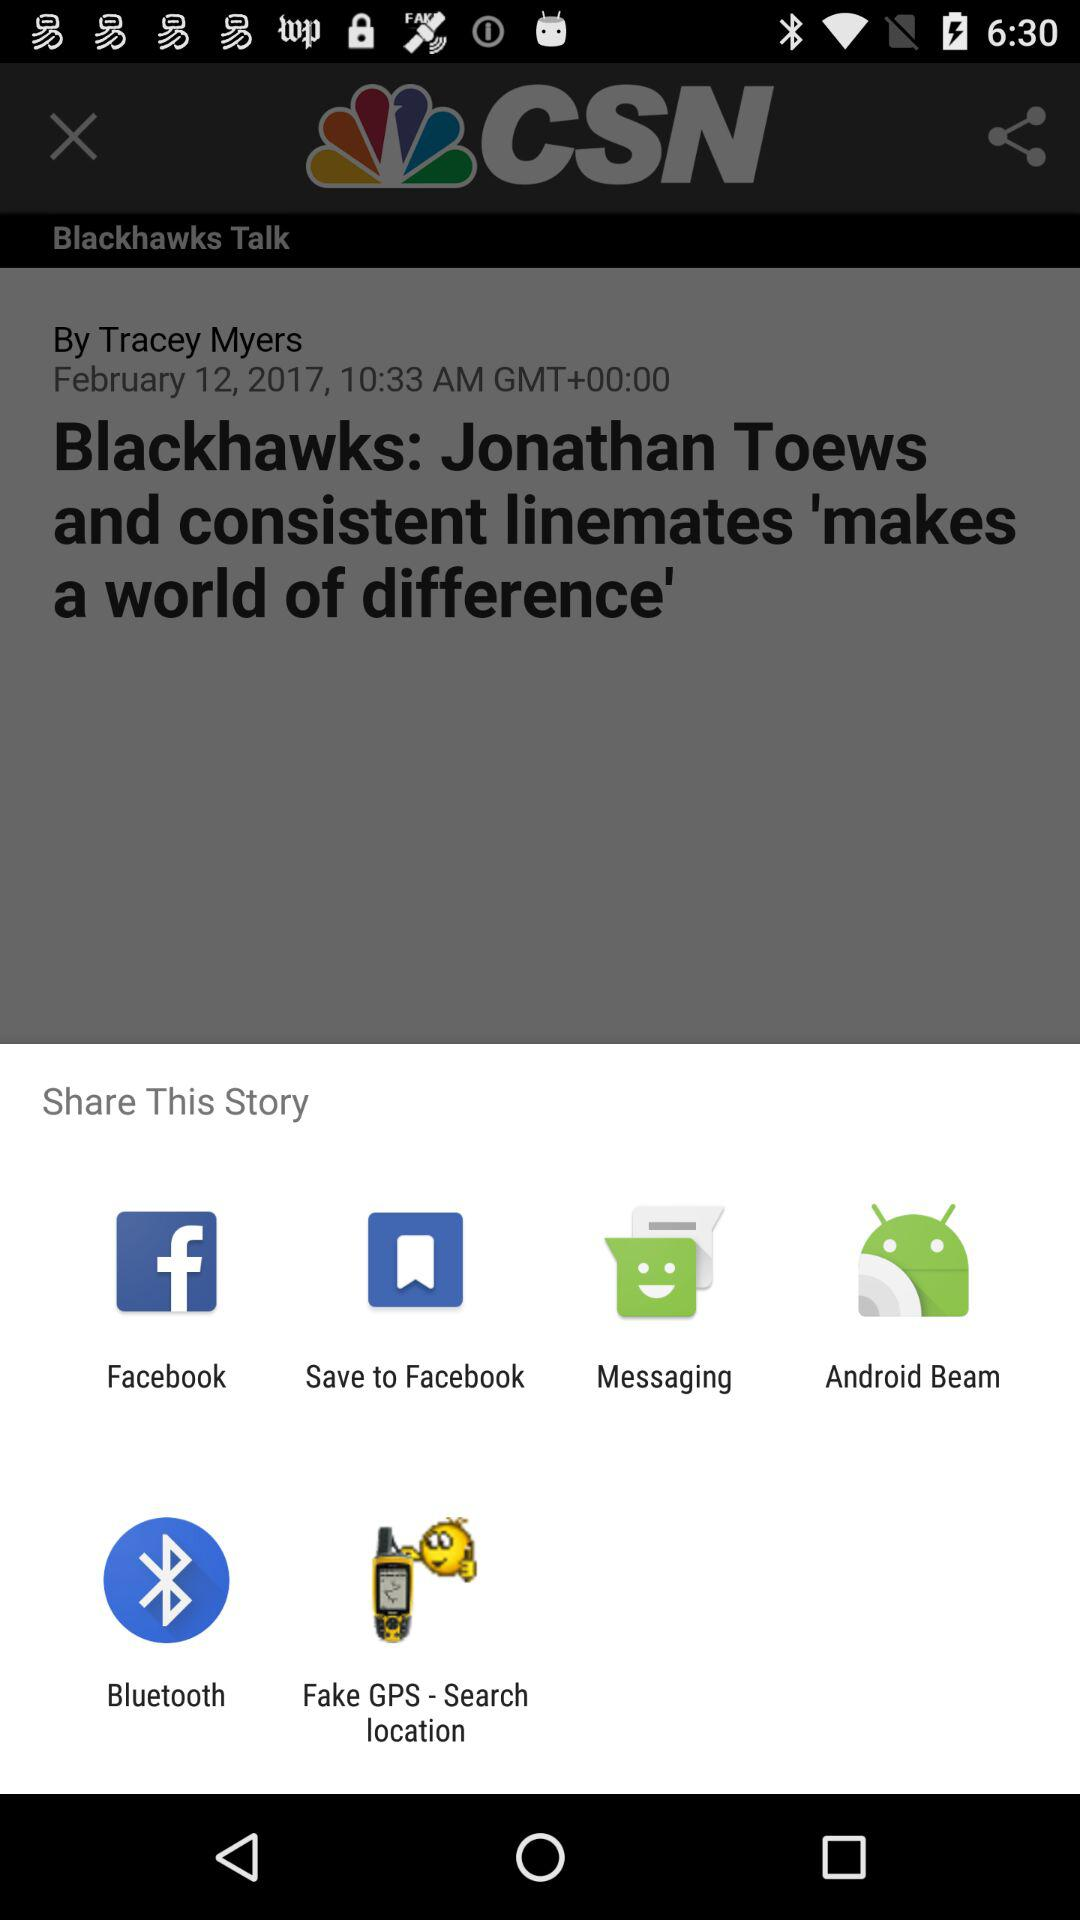What are the different applications through which we can share the story? The different applications through which you can share the story are "Facebook", "Save to Facebook", "Messaging", "Android Beam", "Bluetooth" and "Fake GPS - Search location". 